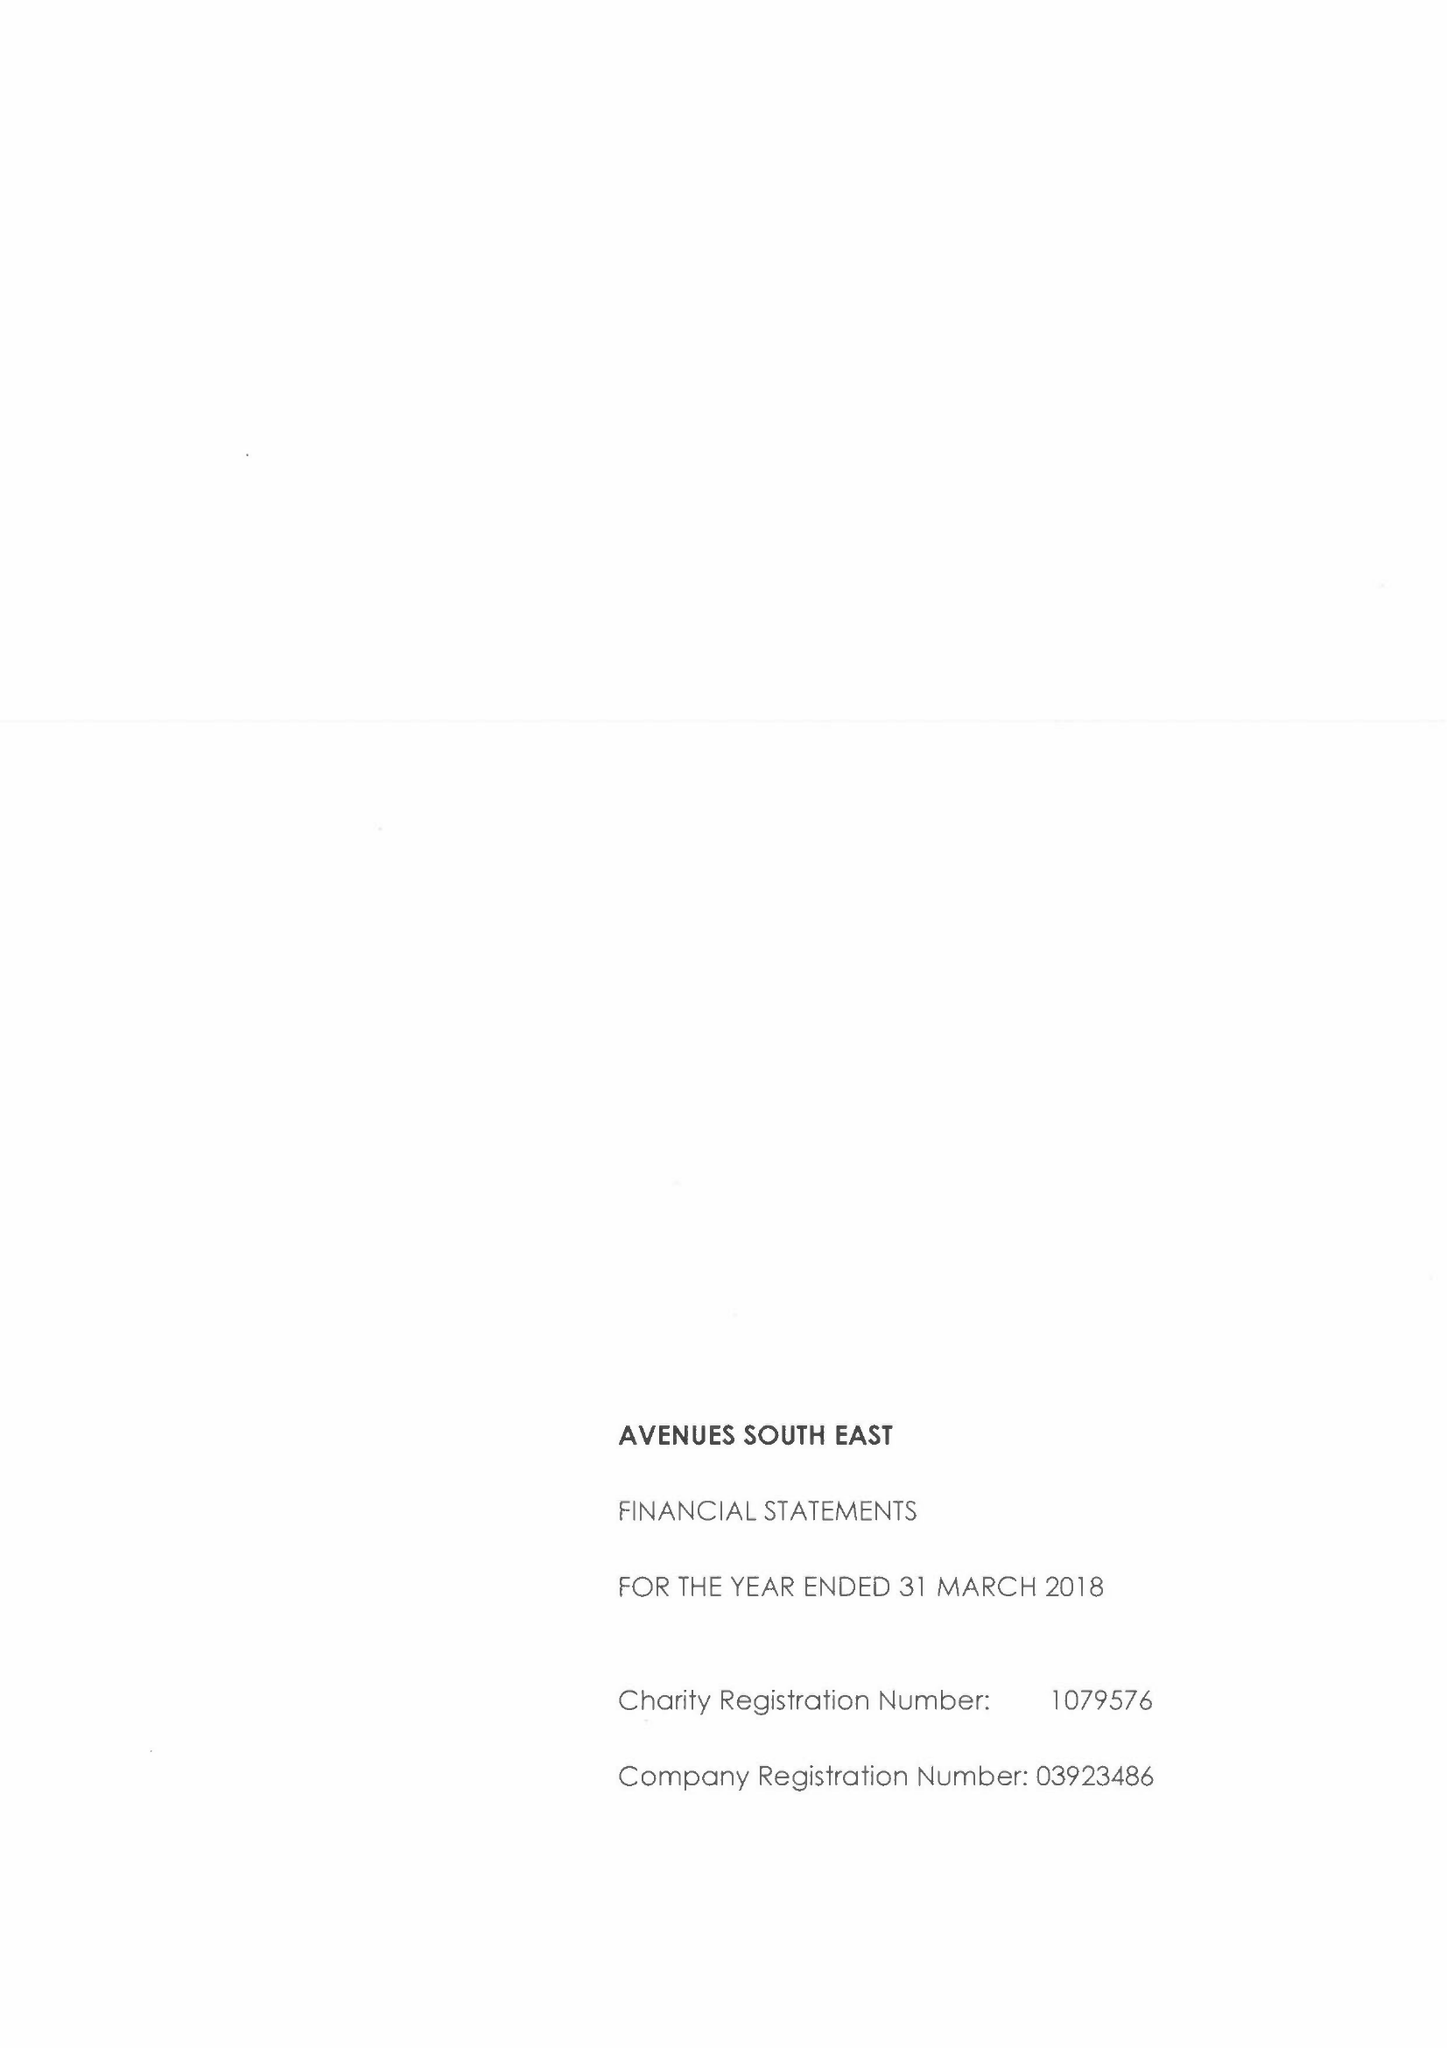What is the value for the spending_annually_in_british_pounds?
Answer the question using a single word or phrase. 16611000.00 